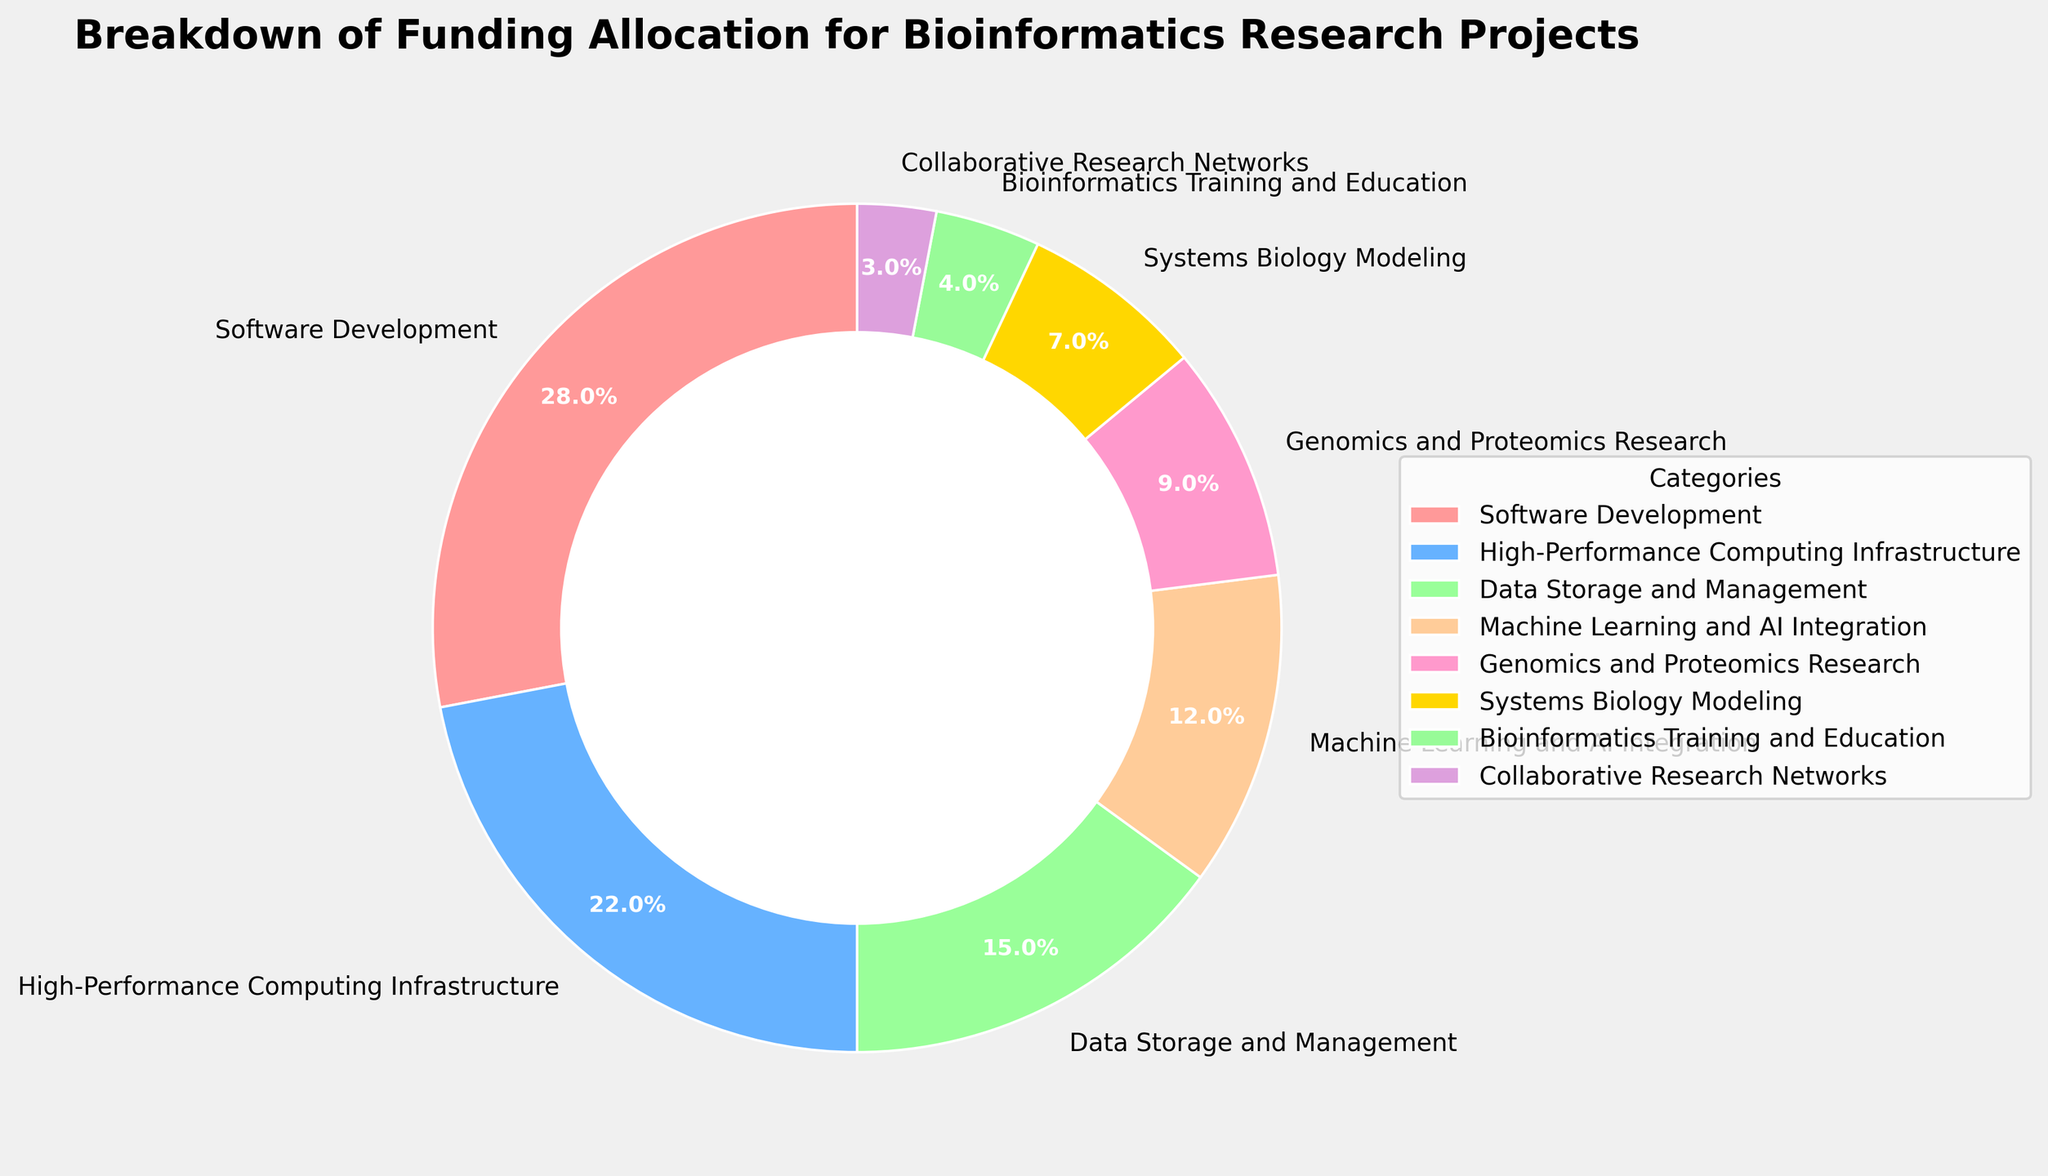What is the largest funding category? The largest segment of the pie chart is labeled "Software Development" which has the biggest wedge and is listed first in the legend.
Answer: Software Development Which funding category received the least percentage? The smallest segment of the pie chart is labeled "Collaborative Research Networks," which has the smallest wedge and is the last in the legend.
Answer: Collaborative Research Networks What is the combined funding percentage for High-Performance Computing Infrastructure and Machine Learning and AI Integration? The pie chart shows individual percentages: High-Performance Computing Infrastructure (22%) and Machine Learning and AI Integration (12%). Summing these gives 22 + 12.
Answer: 34% Which categories have a funding percentage of less than 10%? The pie chart shows that the categories with less than 10% are Genomics and Proteomics Research (9%), Systems Biology Modeling (7%), Bioinformatics Training and Education (4%), and Collaborative Research Networks (3%).
Answer: Genomics and Proteomics Research, Systems Biology Modeling, Bioinformatics Training and Education, Collaborative Research Networks How does the funding for Data Storage and Management compare to that for Systems Biology Modeling? Data Storage and Management has a wedge labeled 15%, whereas Systems Biology Modeling has a wedge labeled 7%. Data Storage and Management is greater than Systems Biology Modeling.
Answer: Data Storage and Management is greater What is the total percentage for categories related to biological research (Genomics and Proteomics Research and Systems Biology Modeling)? The pie chart shows Genomics and Proteomics Research at 9% and Systems Biology Modeling at 7%. Summing these gives 9 + 7.
Answer: 16% Which category is represented by the greenish color, and what funding percentage does it have? The category represented by greenish color is labeled "High-Performance Computing Infrastructure" with a percentage of 22%.
Answer: High-Performance Computing Infrastructure, 22% What is the difference in funding percentages between Bioinformatics Training and Education and Collaborative Research Networks? The pie chart shows Bioinformatics Training and Education at 4% and Collaborative Research Networks at 3%. The difference is 4 - 3.
Answer: 1% What percentage of the funding is allocated to machine learning (Machine Learning and AI Integration)? The pie chart has a labeled wedge for Machine Learning and AI Integration with a percentage of 12%.
Answer: 12% What is the funding percentage for the categories directly related to computational modeling (Systems Biology Modeling and Bioinformatics Training and Education)? The pie chart shows Systems Biology Modeling at 7% and Bioinformatics Training and Education at 4%. Summing these gives 7 + 4.
Answer: 11% 